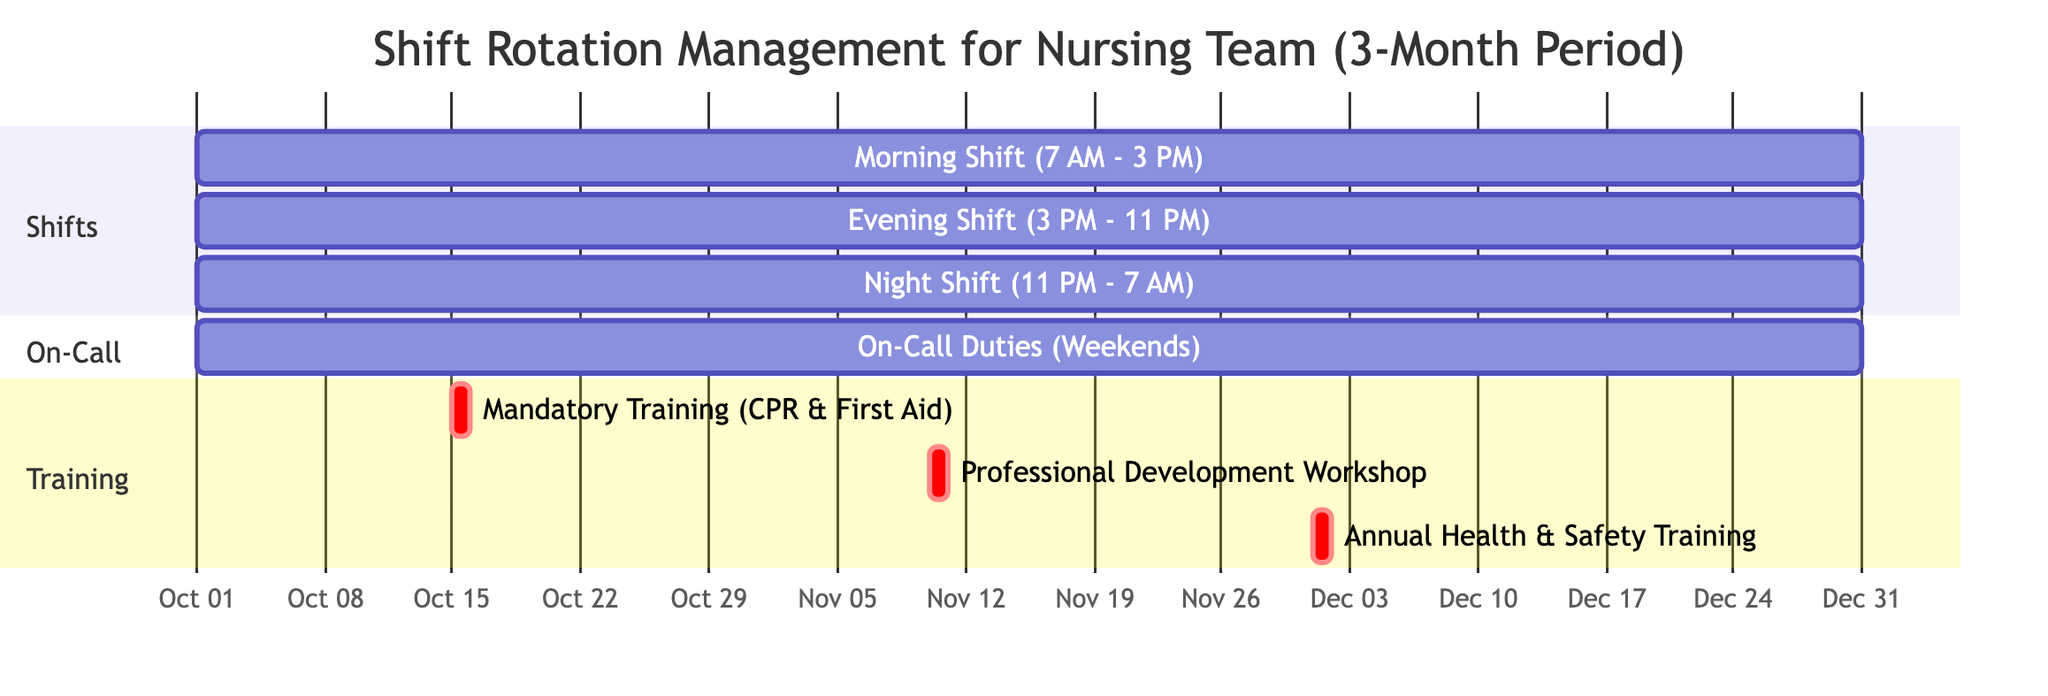What are the start and end dates for the Morning Shift? The Morning Shift starts on October 1, 2023, and ends on December 31, 2023, as indicated in the diagram.
Answer: October 1, 2023 - December 31, 2023 How many training sessions are scheduled in total? The diagram includes three training sessions: Mandatory Training, Professional Development Workshop, and Annual Health and Safety Training, which can be counted from the Training section.
Answer: 3 When does the Annual Health and Safety Training occur? The diagram shows the date for the Annual Health and Safety Training as December 1, 2023, listed under the Training section.
Answer: December 1, 2023 What is the duration of the On-Call Duties? The On-Call Duties are scheduled from October 1, 2023, to December 31, 2023, which gives a duration of three months, as reflected under the On-Call section.
Answer: 3 months Which shift has the earliest start time? The Morning Shift, which starts at 7 AM, is earlier than both the Evening Shift (3 PM) and Night Shift (11 PM) as per the details provided.
Answer: Morning Shift What is the interval between the Mandatory Training Session and the Professional Development Workshop? The Mandatory Training is on October 15, 2023, and the Professional Development Workshop is on November 10, 2023, yielding a 26-day interval between those dates.
Answer: 26 days How many shifts are being managed in this rotation? The diagram lists three distinct shifts: Morning, Evening, and Night, visible in the Shifts section.
Answer: 3 During which month does the Professional Development Workshop take place? The Professional Development Workshop is scheduled for November 10, 2023, which falls in the month of November according to the Training section.
Answer: November What details are provided about the On-Call Duties? The On-Call Duties occur every other weekend, specifically on Saturday and Sunday, as outlined in the On-Call section of the diagram.
Answer: Every other weekend, Sat-Sun 